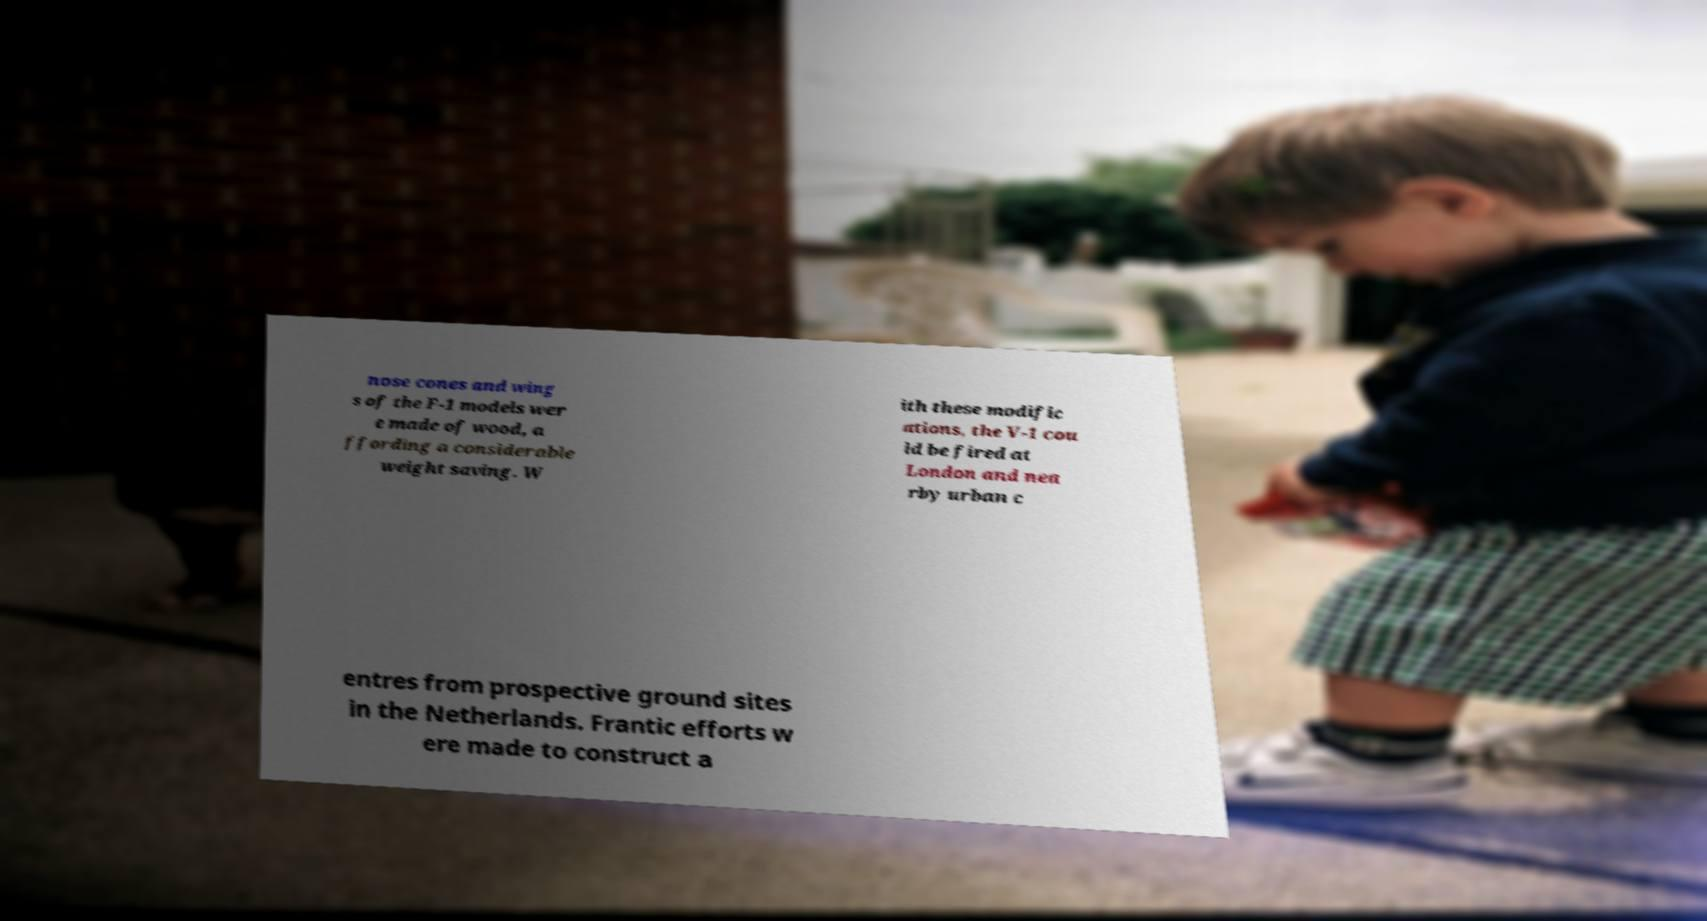What messages or text are displayed in this image? I need them in a readable, typed format. nose cones and wing s of the F-1 models wer e made of wood, a ffording a considerable weight saving. W ith these modific ations, the V-1 cou ld be fired at London and nea rby urban c entres from prospective ground sites in the Netherlands. Frantic efforts w ere made to construct a 